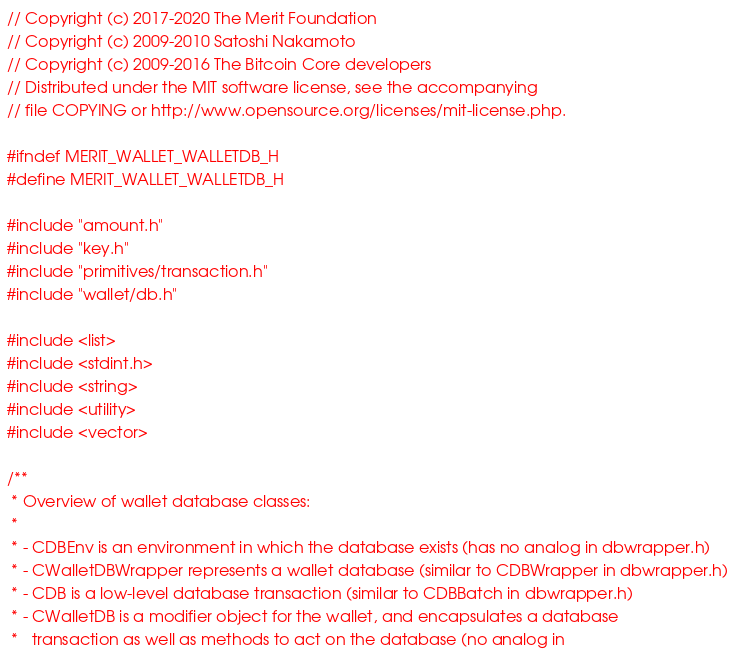<code> <loc_0><loc_0><loc_500><loc_500><_C_>// Copyright (c) 2017-2020 The Merit Foundation
// Copyright (c) 2009-2010 Satoshi Nakamoto
// Copyright (c) 2009-2016 The Bitcoin Core developers
// Distributed under the MIT software license, see the accompanying
// file COPYING or http://www.opensource.org/licenses/mit-license.php.

#ifndef MERIT_WALLET_WALLETDB_H
#define MERIT_WALLET_WALLETDB_H

#include "amount.h"
#include "key.h"
#include "primitives/transaction.h"
#include "wallet/db.h"

#include <list>
#include <stdint.h>
#include <string>
#include <utility>
#include <vector>

/**
 * Overview of wallet database classes:
 *
 * - CDBEnv is an environment in which the database exists (has no analog in dbwrapper.h)
 * - CWalletDBWrapper represents a wallet database (similar to CDBWrapper in dbwrapper.h)
 * - CDB is a low-level database transaction (similar to CDBBatch in dbwrapper.h)
 * - CWalletDB is a modifier object for the wallet, and encapsulates a database
 *   transaction as well as methods to act on the database (no analog in</code> 